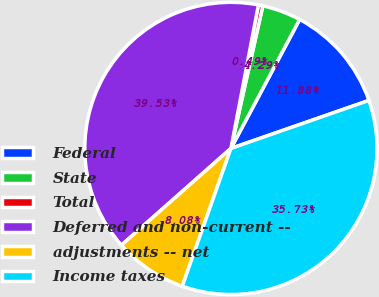Convert chart. <chart><loc_0><loc_0><loc_500><loc_500><pie_chart><fcel>Federal<fcel>State<fcel>Total<fcel>Deferred and non-current --<fcel>adjustments -- net<fcel>Income taxes<nl><fcel>11.88%<fcel>4.29%<fcel>0.49%<fcel>39.53%<fcel>8.08%<fcel>35.73%<nl></chart> 